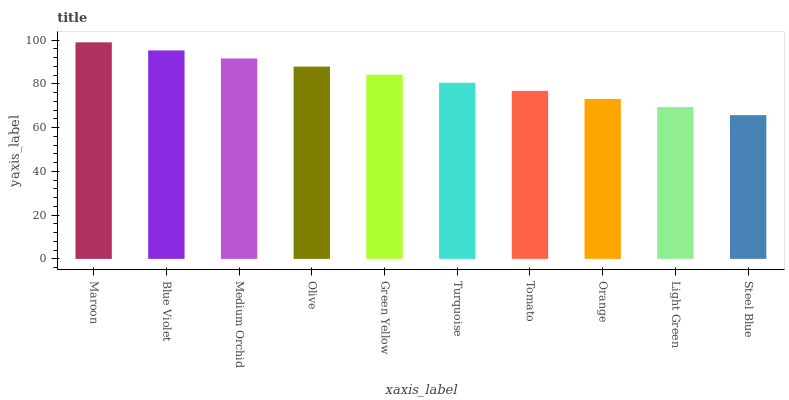Is Steel Blue the minimum?
Answer yes or no. Yes. Is Maroon the maximum?
Answer yes or no. Yes. Is Blue Violet the minimum?
Answer yes or no. No. Is Blue Violet the maximum?
Answer yes or no. No. Is Maroon greater than Blue Violet?
Answer yes or no. Yes. Is Blue Violet less than Maroon?
Answer yes or no. Yes. Is Blue Violet greater than Maroon?
Answer yes or no. No. Is Maroon less than Blue Violet?
Answer yes or no. No. Is Green Yellow the high median?
Answer yes or no. Yes. Is Turquoise the low median?
Answer yes or no. Yes. Is Maroon the high median?
Answer yes or no. No. Is Steel Blue the low median?
Answer yes or no. No. 